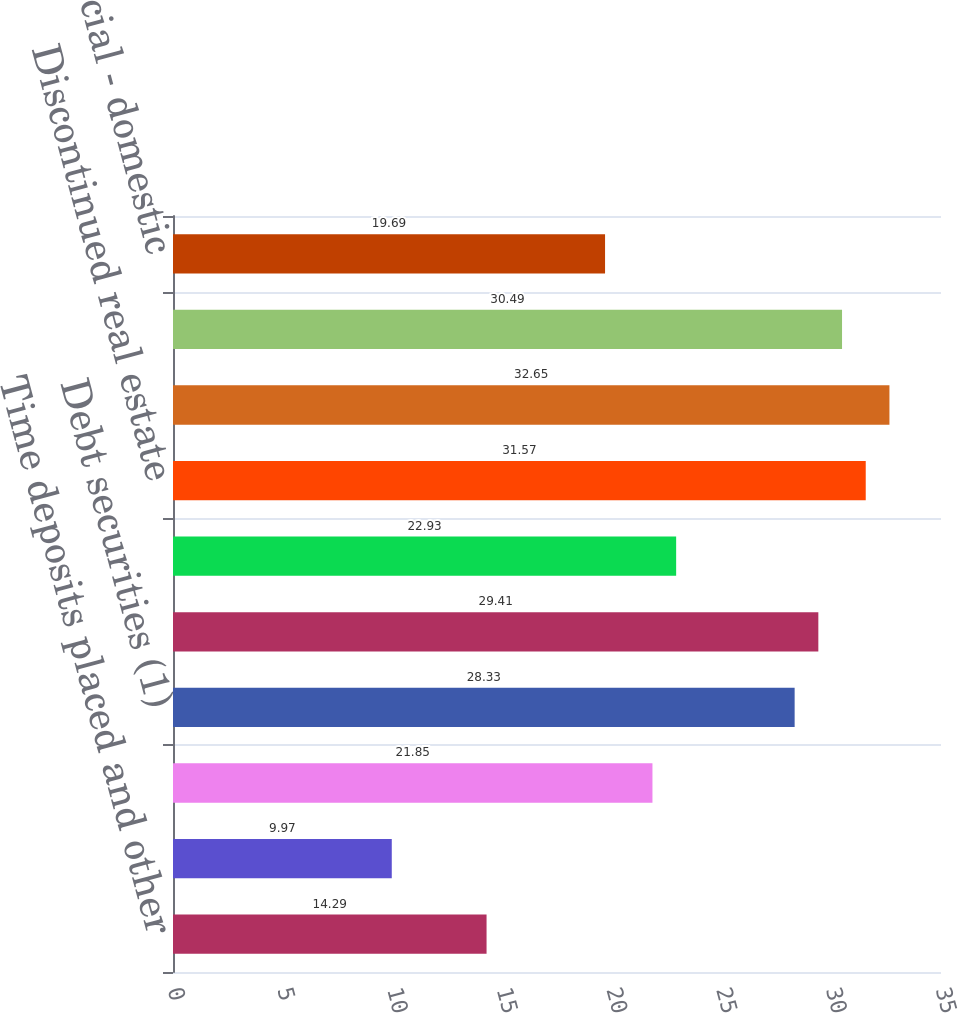<chart> <loc_0><loc_0><loc_500><loc_500><bar_chart><fcel>Time deposits placed and other<fcel>Federal funds sold and<fcel>Trading account assets<fcel>Debt securities (1)<fcel>Residential mortgage (3)<fcel>Home equity<fcel>Discontinued real estate<fcel>Credit card - domestic<fcel>Total consumer<fcel>Commercial - domestic<nl><fcel>14.29<fcel>9.97<fcel>21.85<fcel>28.33<fcel>29.41<fcel>22.93<fcel>31.57<fcel>32.65<fcel>30.49<fcel>19.69<nl></chart> 